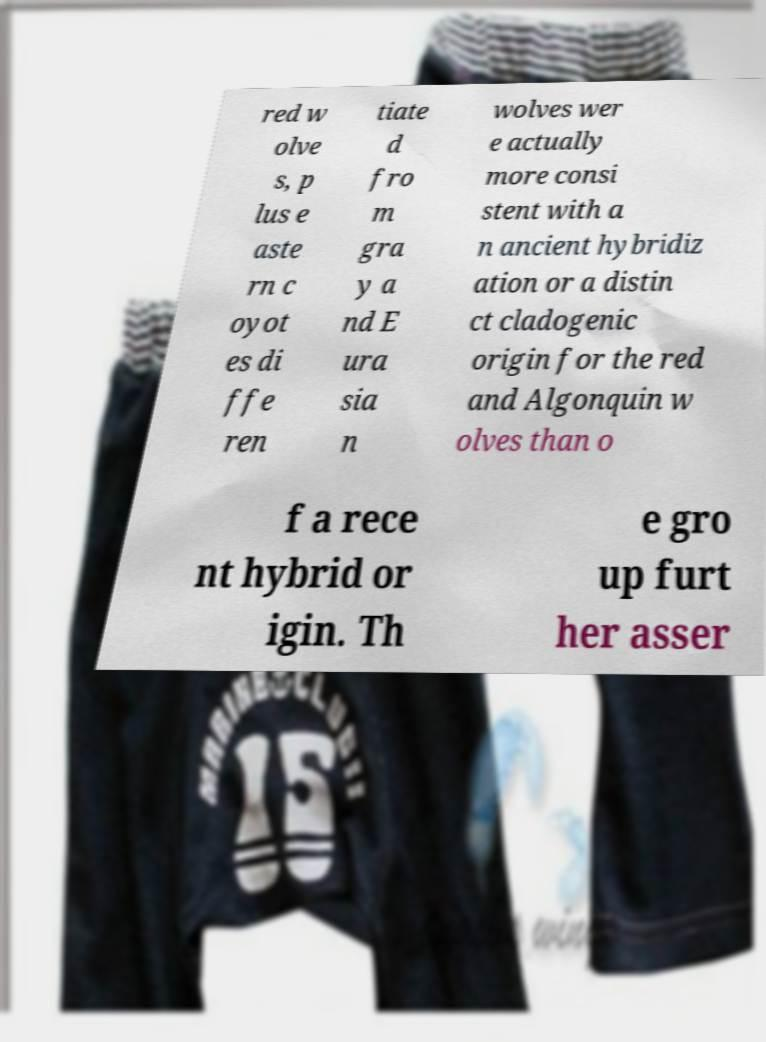Could you extract and type out the text from this image? red w olve s, p lus e aste rn c oyot es di ffe ren tiate d fro m gra y a nd E ura sia n wolves wer e actually more consi stent with a n ancient hybridiz ation or a distin ct cladogenic origin for the red and Algonquin w olves than o f a rece nt hybrid or igin. Th e gro up furt her asser 